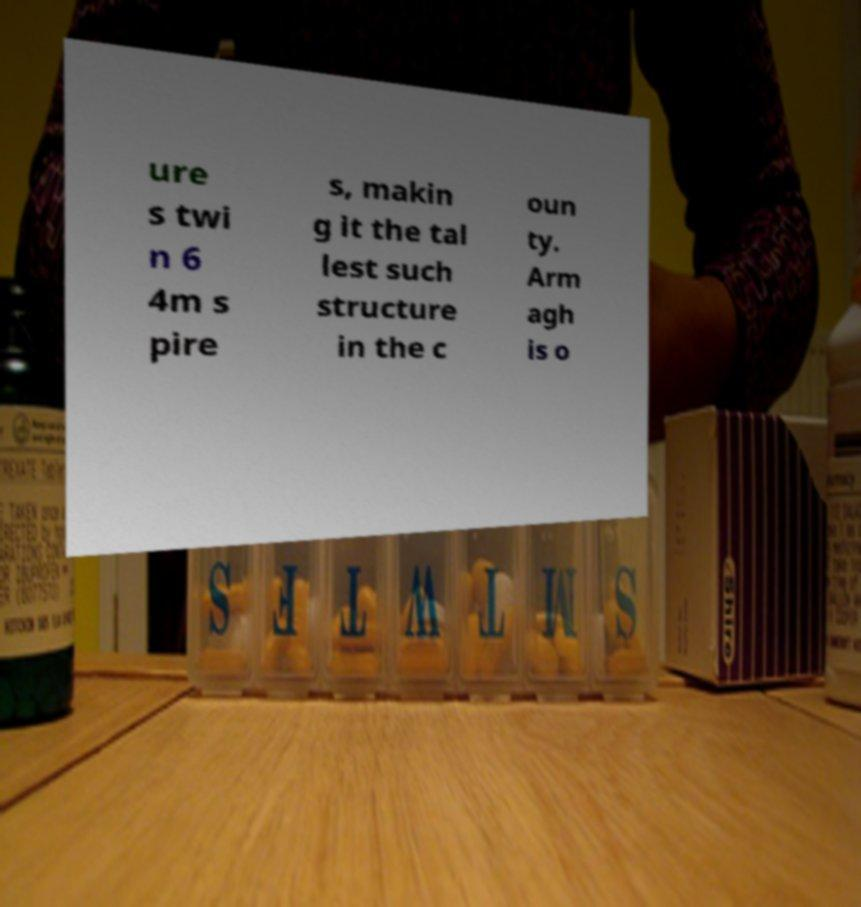Can you accurately transcribe the text from the provided image for me? ure s twi n 6 4m s pire s, makin g it the tal lest such structure in the c oun ty. Arm agh is o 